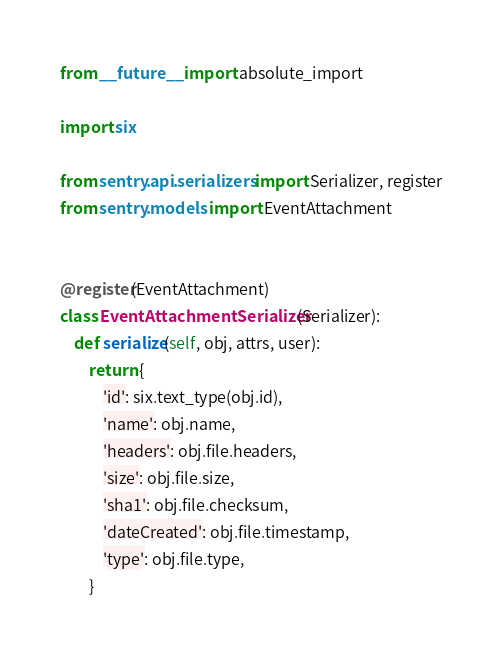Convert code to text. <code><loc_0><loc_0><loc_500><loc_500><_Python_>from __future__ import absolute_import

import six

from sentry.api.serializers import Serializer, register
from sentry.models import EventAttachment


@register(EventAttachment)
class EventAttachmentSerializer(Serializer):
    def serialize(self, obj, attrs, user):
        return {
            'id': six.text_type(obj.id),
            'name': obj.name,
            'headers': obj.file.headers,
            'size': obj.file.size,
            'sha1': obj.file.checksum,
            'dateCreated': obj.file.timestamp,
            'type': obj.file.type,
        }
</code> 